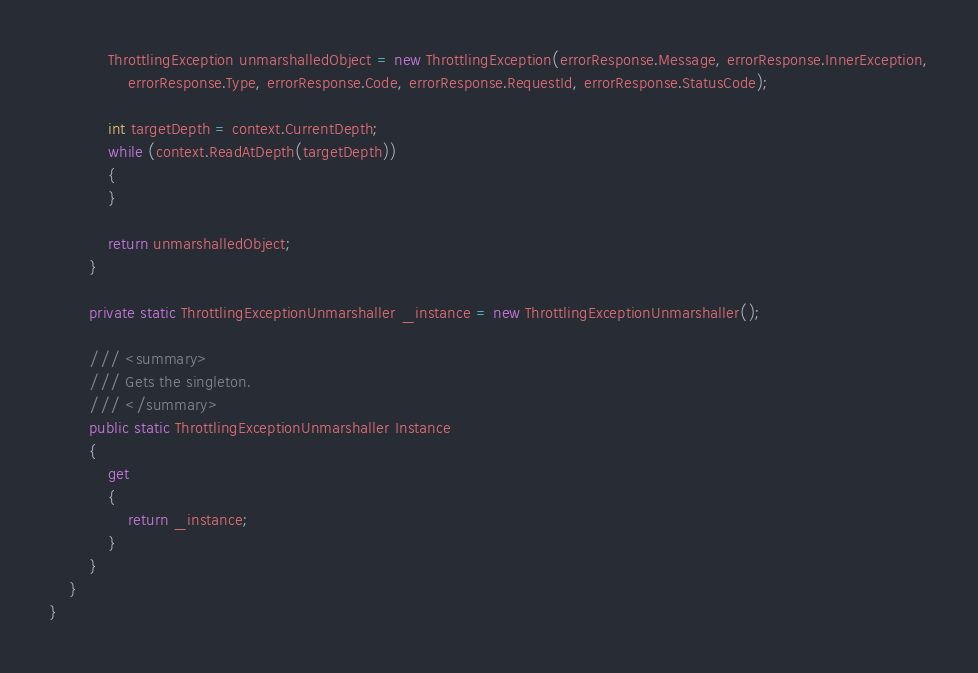<code> <loc_0><loc_0><loc_500><loc_500><_C#_>            ThrottlingException unmarshalledObject = new ThrottlingException(errorResponse.Message, errorResponse.InnerException,
                errorResponse.Type, errorResponse.Code, errorResponse.RequestId, errorResponse.StatusCode);
        
            int targetDepth = context.CurrentDepth;
            while (context.ReadAtDepth(targetDepth))
            {
            }
          
            return unmarshalledObject;
        }

        private static ThrottlingExceptionUnmarshaller _instance = new ThrottlingExceptionUnmarshaller();        

        /// <summary>
        /// Gets the singleton.
        /// </summary>  
        public static ThrottlingExceptionUnmarshaller Instance
        {
            get
            {
                return _instance;
            }
        }
    }
}</code> 